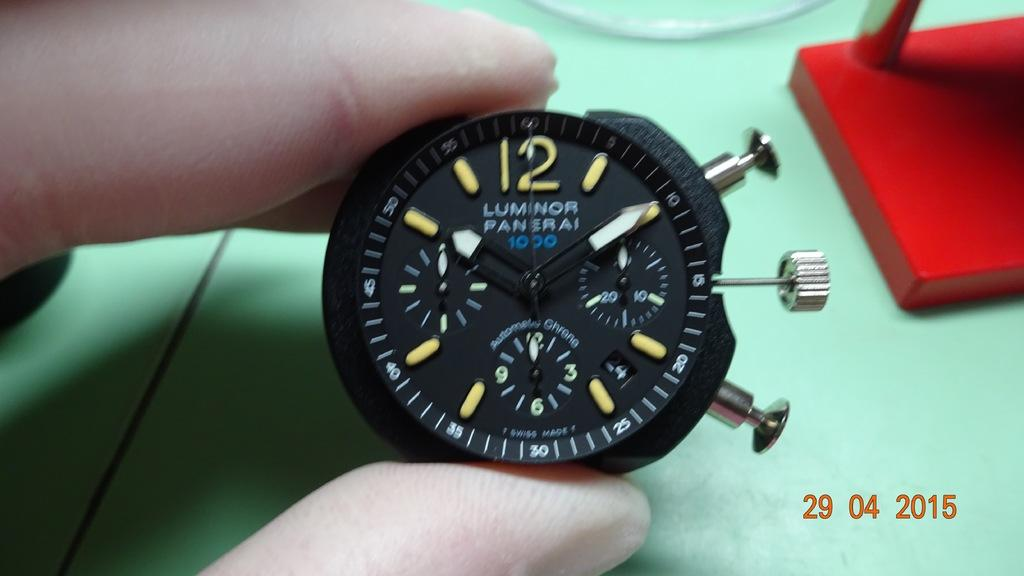<image>
Describe the image concisely. A person is holding a watch that says Luminor Panerai. 